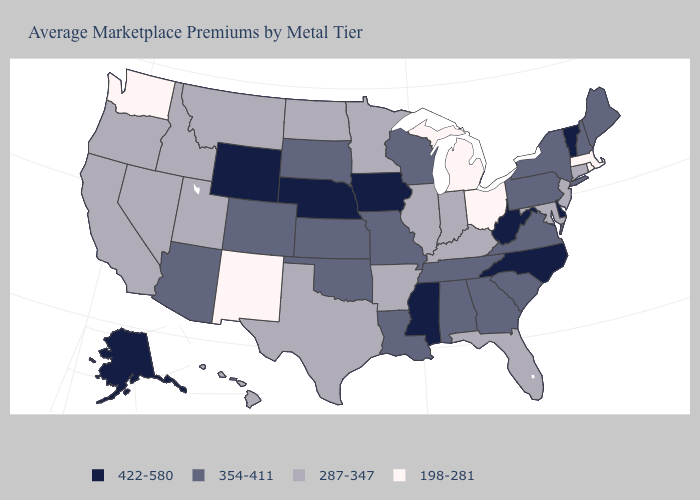Does Michigan have the lowest value in the USA?
Give a very brief answer. Yes. Does Ohio have the lowest value in the MidWest?
Be succinct. Yes. Name the states that have a value in the range 354-411?
Concise answer only. Alabama, Arizona, Colorado, Georgia, Kansas, Louisiana, Maine, Missouri, New Hampshire, New York, Oklahoma, Pennsylvania, South Carolina, South Dakota, Tennessee, Virginia, Wisconsin. How many symbols are there in the legend?
Quick response, please. 4. What is the value of Vermont?
Quick response, please. 422-580. Is the legend a continuous bar?
Concise answer only. No. What is the highest value in the South ?
Short answer required. 422-580. What is the value of New Jersey?
Give a very brief answer. 287-347. What is the value of Virginia?
Keep it brief. 354-411. Does Arkansas have the lowest value in the South?
Quick response, please. Yes. Which states have the highest value in the USA?
Keep it brief. Alaska, Delaware, Iowa, Mississippi, Nebraska, North Carolina, Vermont, West Virginia, Wyoming. What is the lowest value in states that border New York?
Be succinct. 198-281. What is the lowest value in states that border Oklahoma?
Keep it brief. 198-281. What is the value of Nevada?
Concise answer only. 287-347. Does Arizona have the lowest value in the USA?
Short answer required. No. 